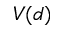Convert formula to latex. <formula><loc_0><loc_0><loc_500><loc_500>V ( d )</formula> 